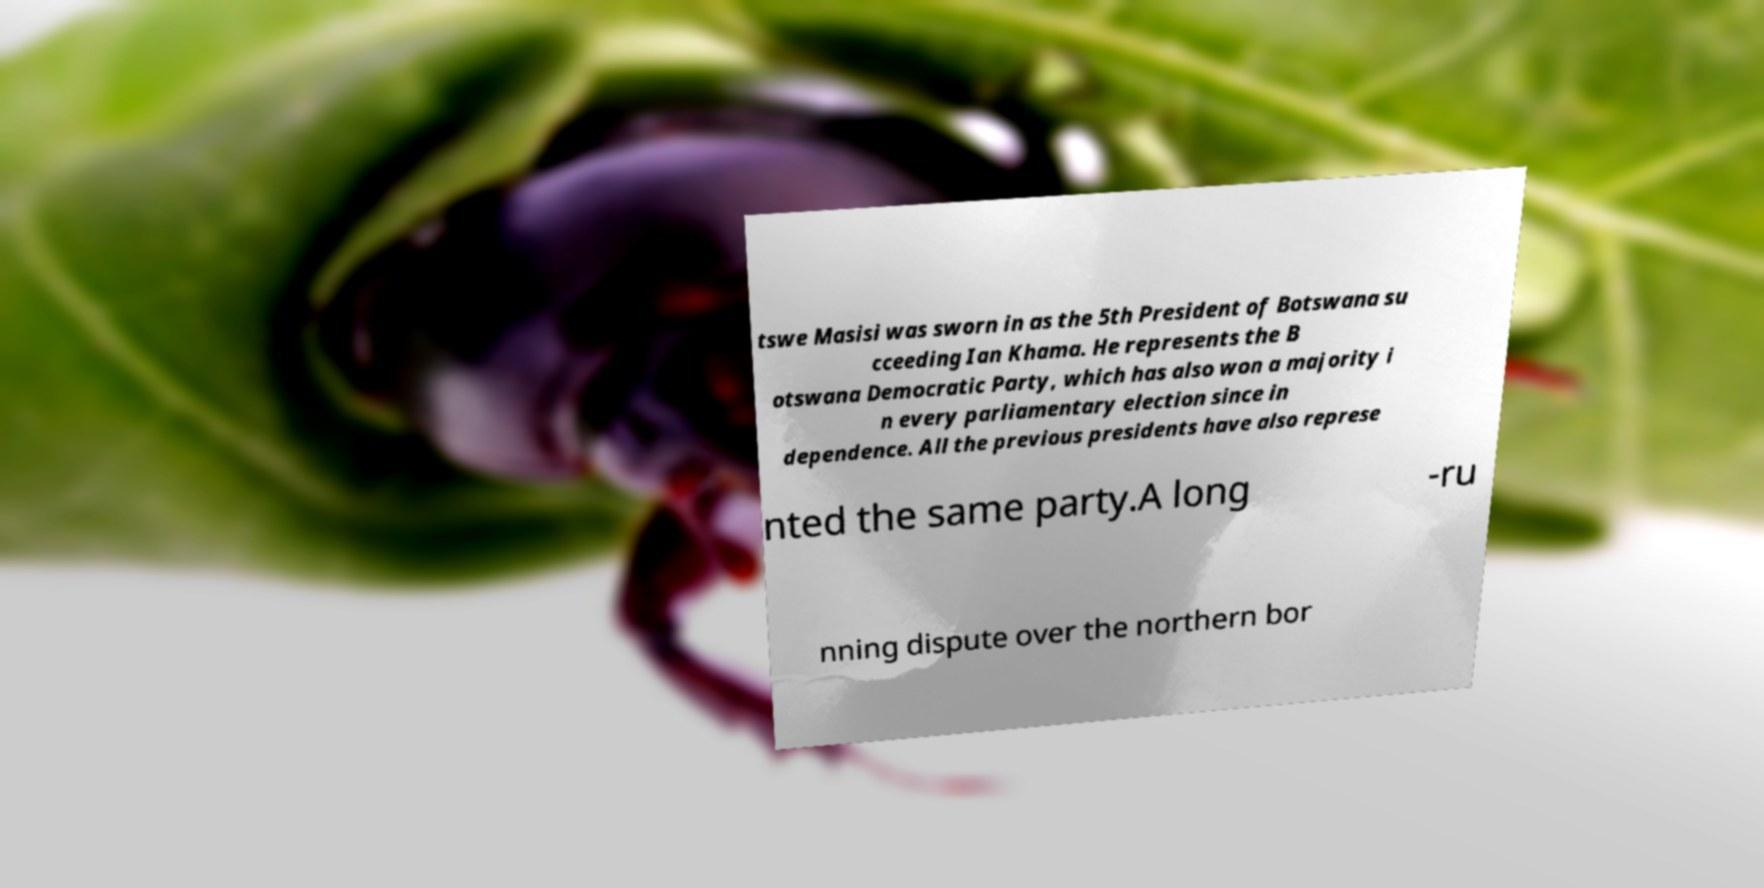Could you assist in decoding the text presented in this image and type it out clearly? tswe Masisi was sworn in as the 5th President of Botswana su cceeding Ian Khama. He represents the B otswana Democratic Party, which has also won a majority i n every parliamentary election since in dependence. All the previous presidents have also represe nted the same party.A long -ru nning dispute over the northern bor 